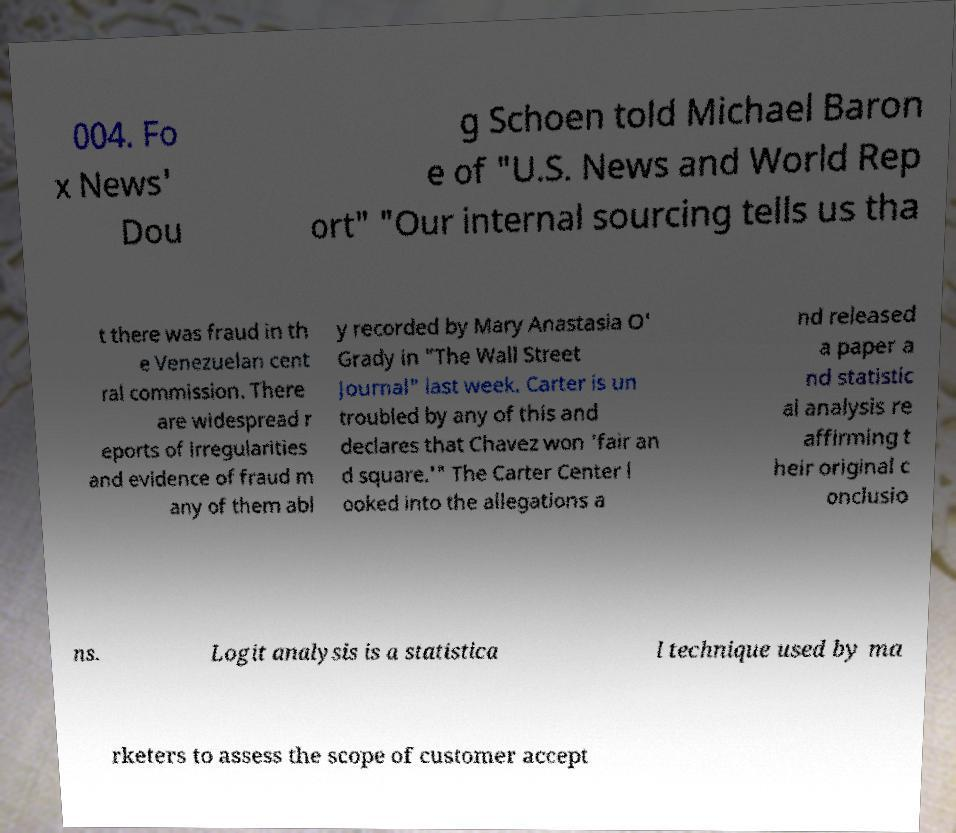There's text embedded in this image that I need extracted. Can you transcribe it verbatim? 004. Fo x News' Dou g Schoen told Michael Baron e of "U.S. News and World Rep ort" "Our internal sourcing tells us tha t there was fraud in th e Venezuelan cent ral commission. There are widespread r eports of irregularities and evidence of fraud m any of them abl y recorded by Mary Anastasia O' Grady in "The Wall Street Journal" last week. Carter is un troubled by any of this and declares that Chavez won 'fair an d square.'" The Carter Center l ooked into the allegations a nd released a paper a nd statistic al analysis re affirming t heir original c onclusio ns. Logit analysis is a statistica l technique used by ma rketers to assess the scope of customer accept 